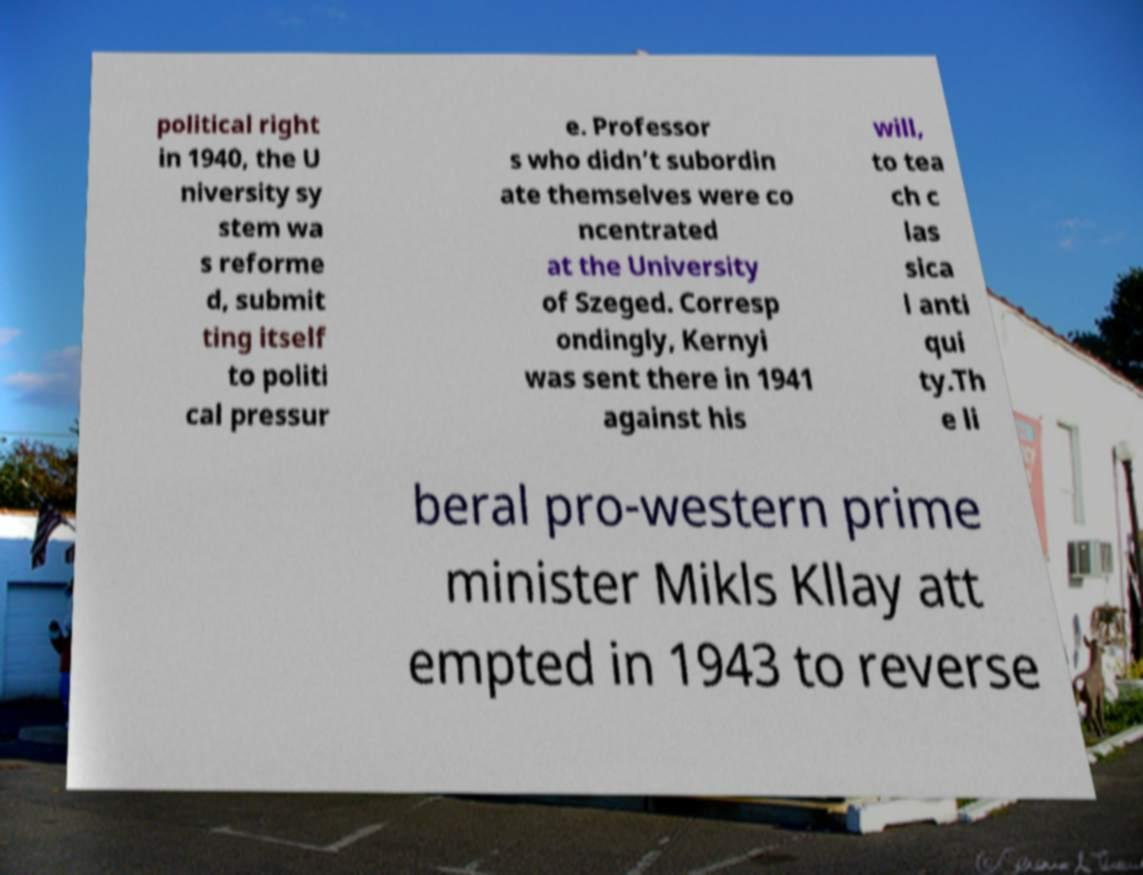I need the written content from this picture converted into text. Can you do that? political right in 1940, the U niversity sy stem wa s reforme d, submit ting itself to politi cal pressur e. Professor s who didn’t subordin ate themselves were co ncentrated at the University of Szeged. Corresp ondingly, Kernyi was sent there in 1941 against his will, to tea ch c las sica l anti qui ty.Th e li beral pro-western prime minister Mikls Kllay att empted in 1943 to reverse 